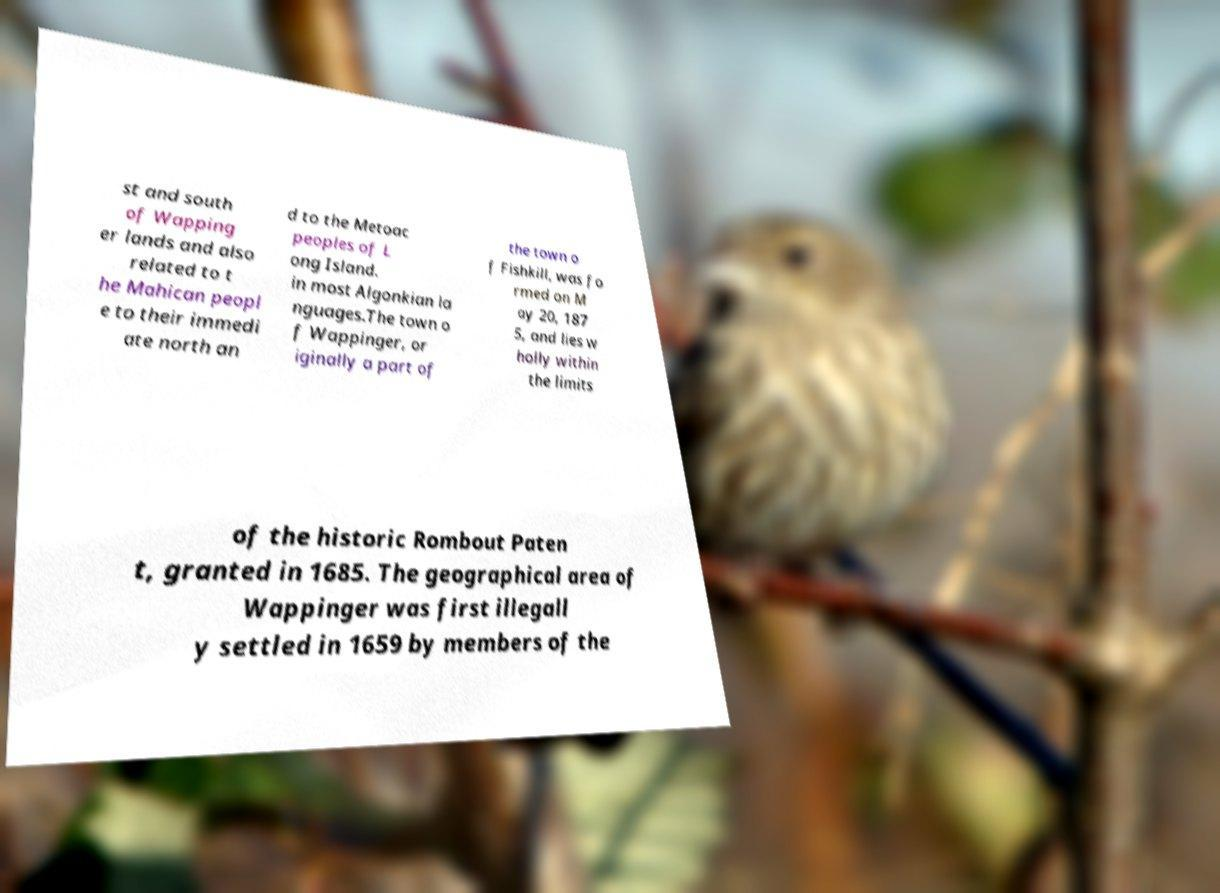For documentation purposes, I need the text within this image transcribed. Could you provide that? st and south of Wapping er lands and also related to t he Mahican peopl e to their immedi ate north an d to the Metoac peoples of L ong Island. in most Algonkian la nguages.The town o f Wappinger, or iginally a part of the town o f Fishkill, was fo rmed on M ay 20, 187 5, and lies w holly within the limits of the historic Rombout Paten t, granted in 1685. The geographical area of Wappinger was first illegall y settled in 1659 by members of the 